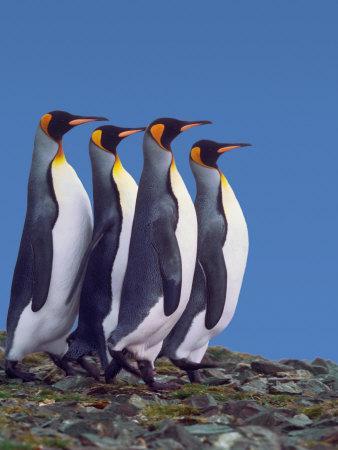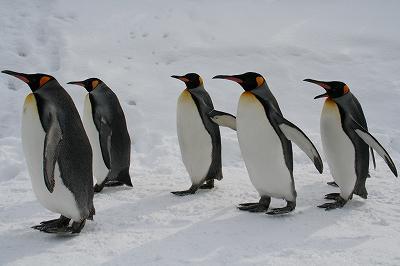The first image is the image on the left, the second image is the image on the right. Given the left and right images, does the statement "One of the images includes a single penguin facing to the left." hold true? Answer yes or no. No. The first image is the image on the left, the second image is the image on the right. Considering the images on both sides, is "Atleast one picture with only one penguin." valid? Answer yes or no. No. 